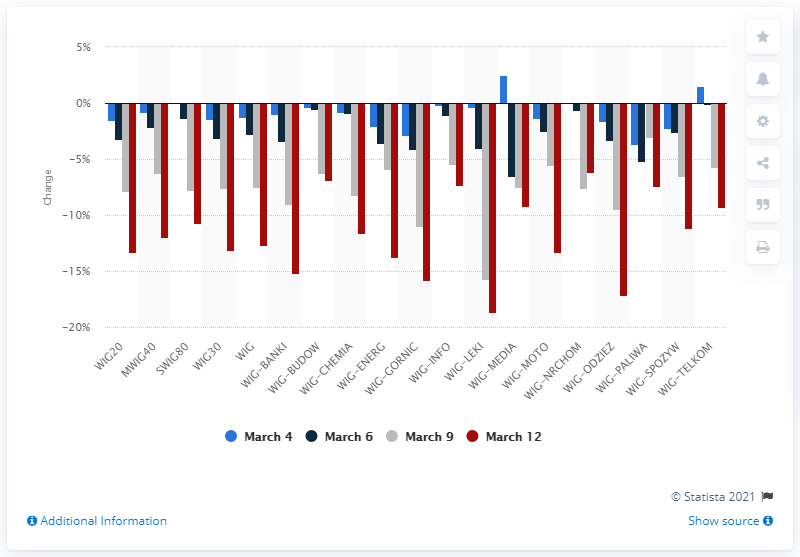Point out several critical features in this image. The worst session this year was WIG20. 